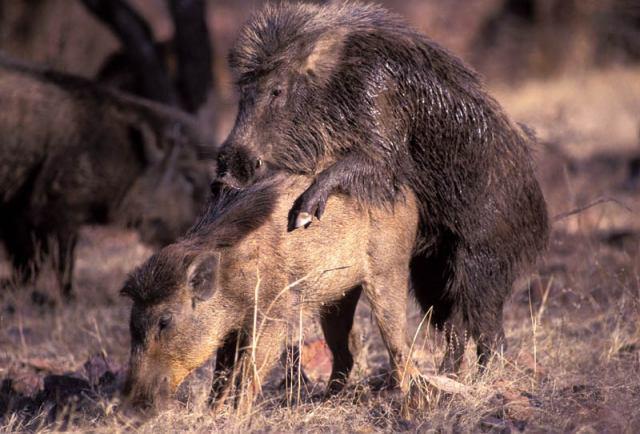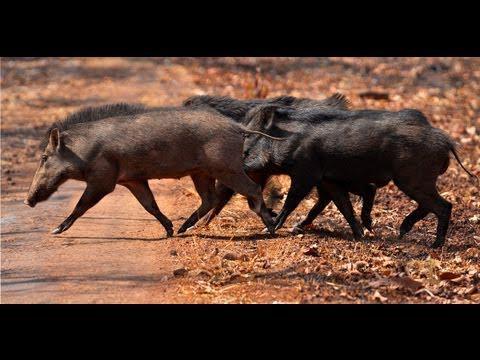The first image is the image on the left, the second image is the image on the right. Given the left and right images, does the statement "The pig in the image on the right is near a body of water." hold true? Answer yes or no. No. 